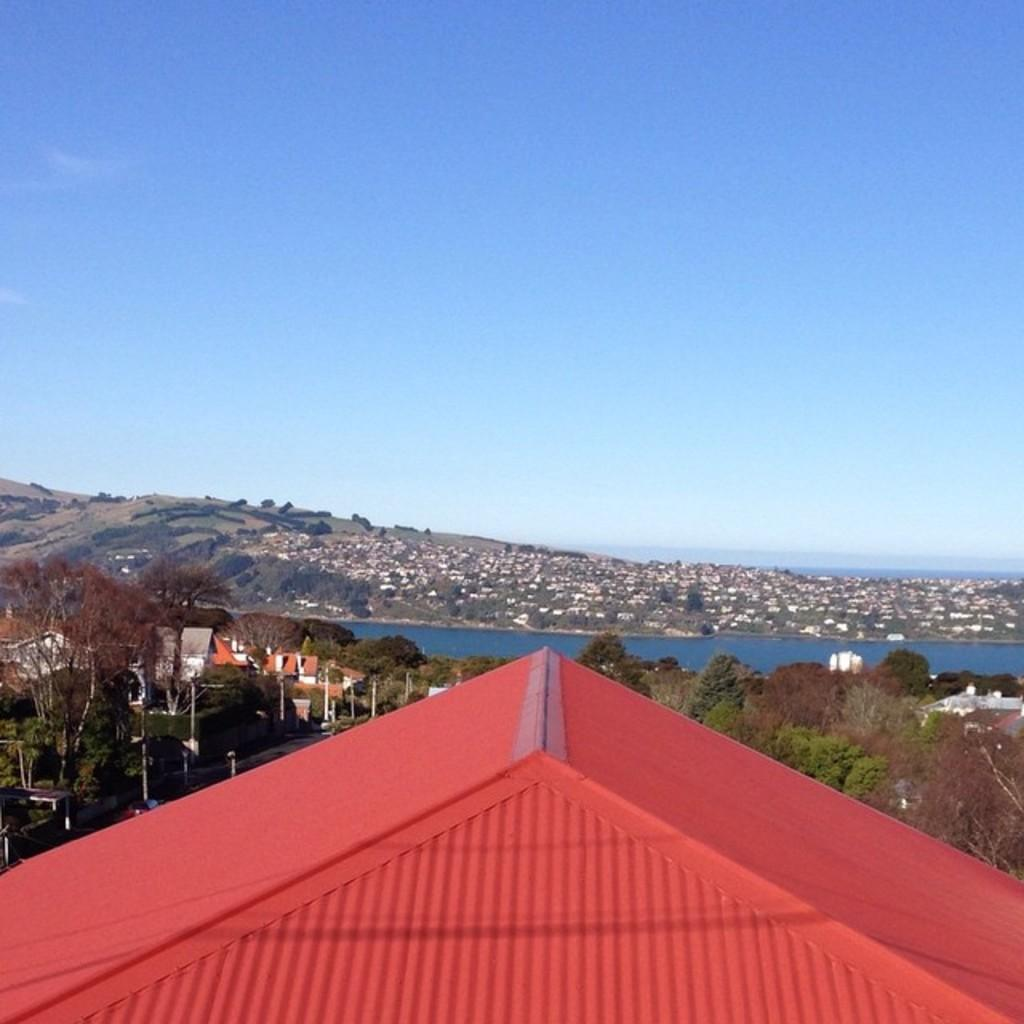What type of natural elements can be seen in the image? There are trees in the image. What type of man-made structures are present in the image? There are buildings in the image. What geographical feature is visible in the image? There is a hill in the image. What body of water is present in the image? There is water in the image. What part of a building can be seen at the bottom of the image? The roof is visible at the bottom of the image. What is visible in the background of the image? The sky is visible in the background of the image. Where is the guide leading the turkeys on the farm in the image? There is no guide, turkeys, or farm present in the image. 